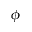<formula> <loc_0><loc_0><loc_500><loc_500>\phi</formula> 